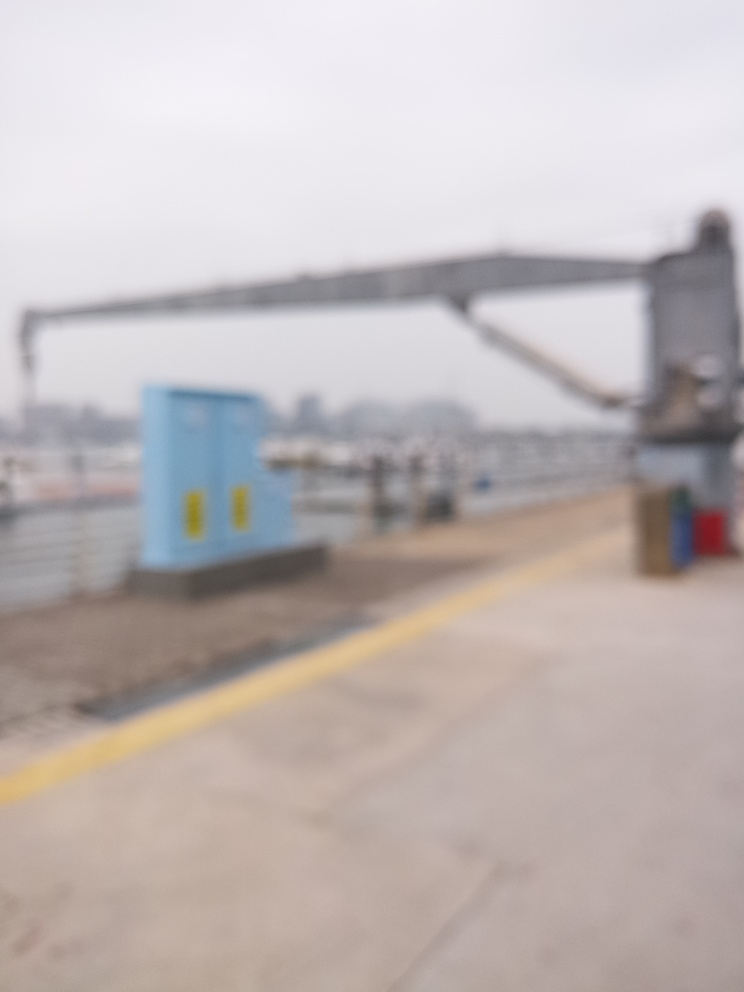Can you describe the setting or location depicted in this image? Due to the blur, details are indistinct, but the presence of a large, metallic structure suggests an industrial or maritime setting, possibly a dock or shipyard. 